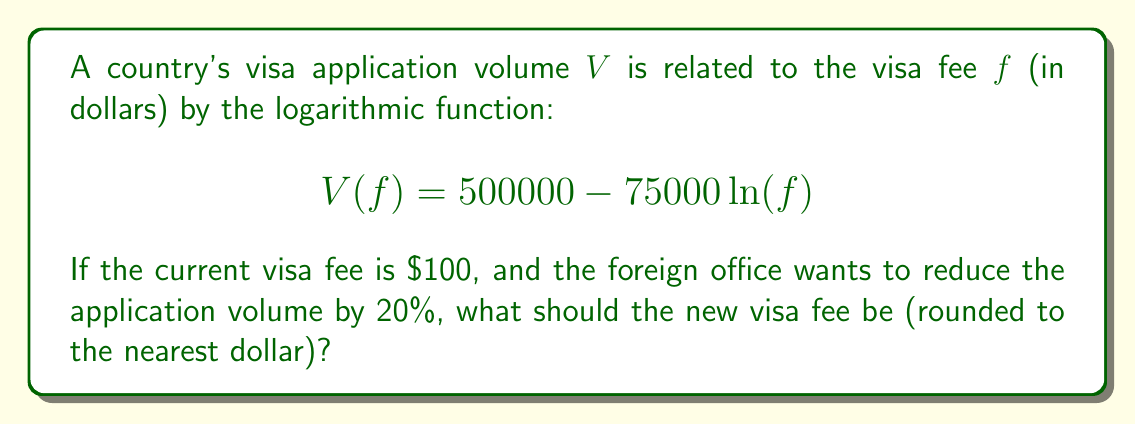Provide a solution to this math problem. Let's approach this step-by-step:

1) First, let's calculate the current application volume with a fee of $100:
   $$V(100) = 500000 - 75000 \ln(100) = 500000 - 75000 * 4.6052 = 154610$$

2) We want to reduce this by 20%, so the new volume should be:
   $$154610 * 0.8 = 123688$$

3) Now we can set up our equation:
   $$123688 = 500000 - 75000 \ln(f)$$

4) Subtract 500000 from both sides:
   $$-376312 = -75000 \ln(f)$$

5) Divide both sides by -75000:
   $$5.0175 = \ln(f)$$

6) Now we can solve for $f$ by applying $e^x$ to both sides:
   $$e^{5.0175} = f$$

7) Calculate this value:
   $$f \approx 151.11$$

8) Rounding to the nearest dollar:
   $$f = 151$$
Answer: $151 